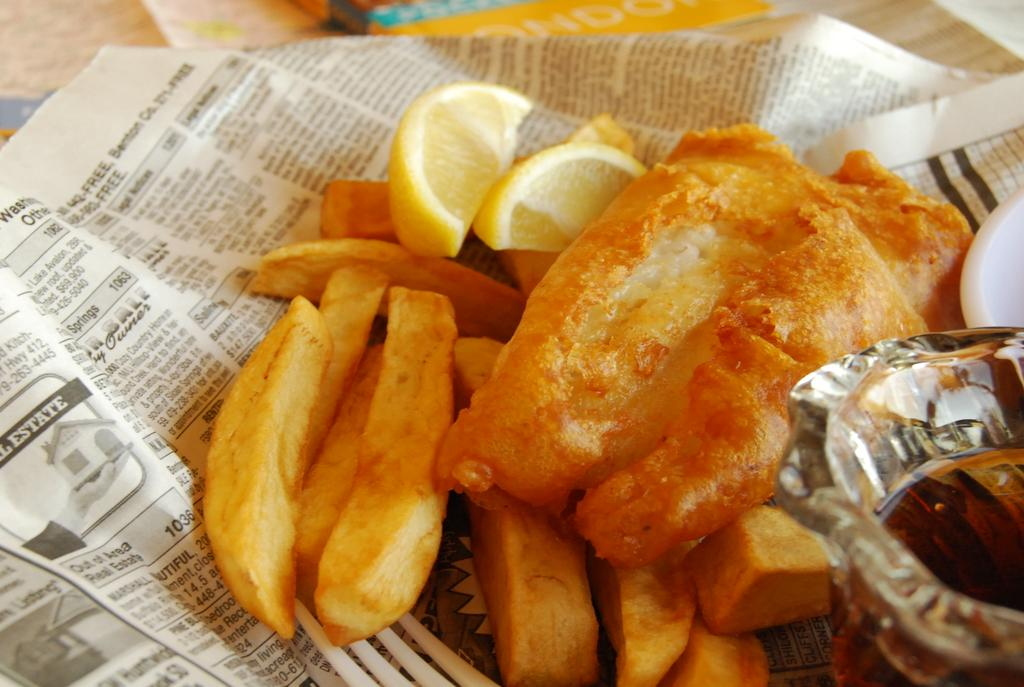Provide a one-sentence caption for the provided image. The word Estate can be seen to the left on the paper the fish and chips are sitting on. 